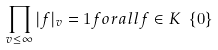<formula> <loc_0><loc_0><loc_500><loc_500>\prod _ { v \leq \infty } | f | _ { v } = 1 f o r a l l f \in K \ \{ 0 \}</formula> 